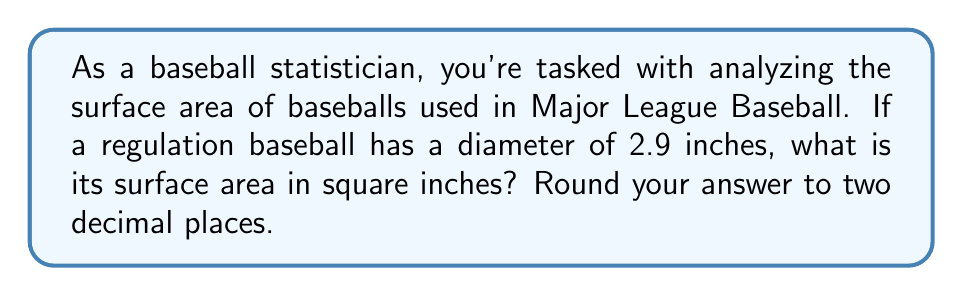Help me with this question. To solve this problem, we'll use the formula for the surface area of a sphere and follow these steps:

1. The formula for the surface area of a sphere is:
   $$A = 4\pi r^2$$
   where $A$ is the surface area and $r$ is the radius of the sphere.

2. We're given the diameter of the baseball, which is 2.9 inches. To find the radius, we divide the diameter by 2:
   $$r = \frac{2.9}{2} = 1.45\text{ inches}$$

3. Now we can substitute this value into our formula:
   $$A = 4\pi (1.45)^2$$

4. Let's calculate this step by step:
   $$A = 4\pi (2.1025)$$
   $$A = 8.41\pi$$

5. Using $\pi \approx 3.14159$, we get:
   $$A \approx 8.41 \times 3.14159 = 26.4207\text{ square inches}$$

6. Rounding to two decimal places:
   $$A \approx 26.42\text{ square inches}$$

This surface area is crucial for understanding how the baseball interacts with the air during flight, which can affect various batting statistics you're familiar with, such as home runs and batting averages.
Answer: $26.42\text{ square inches}$ 